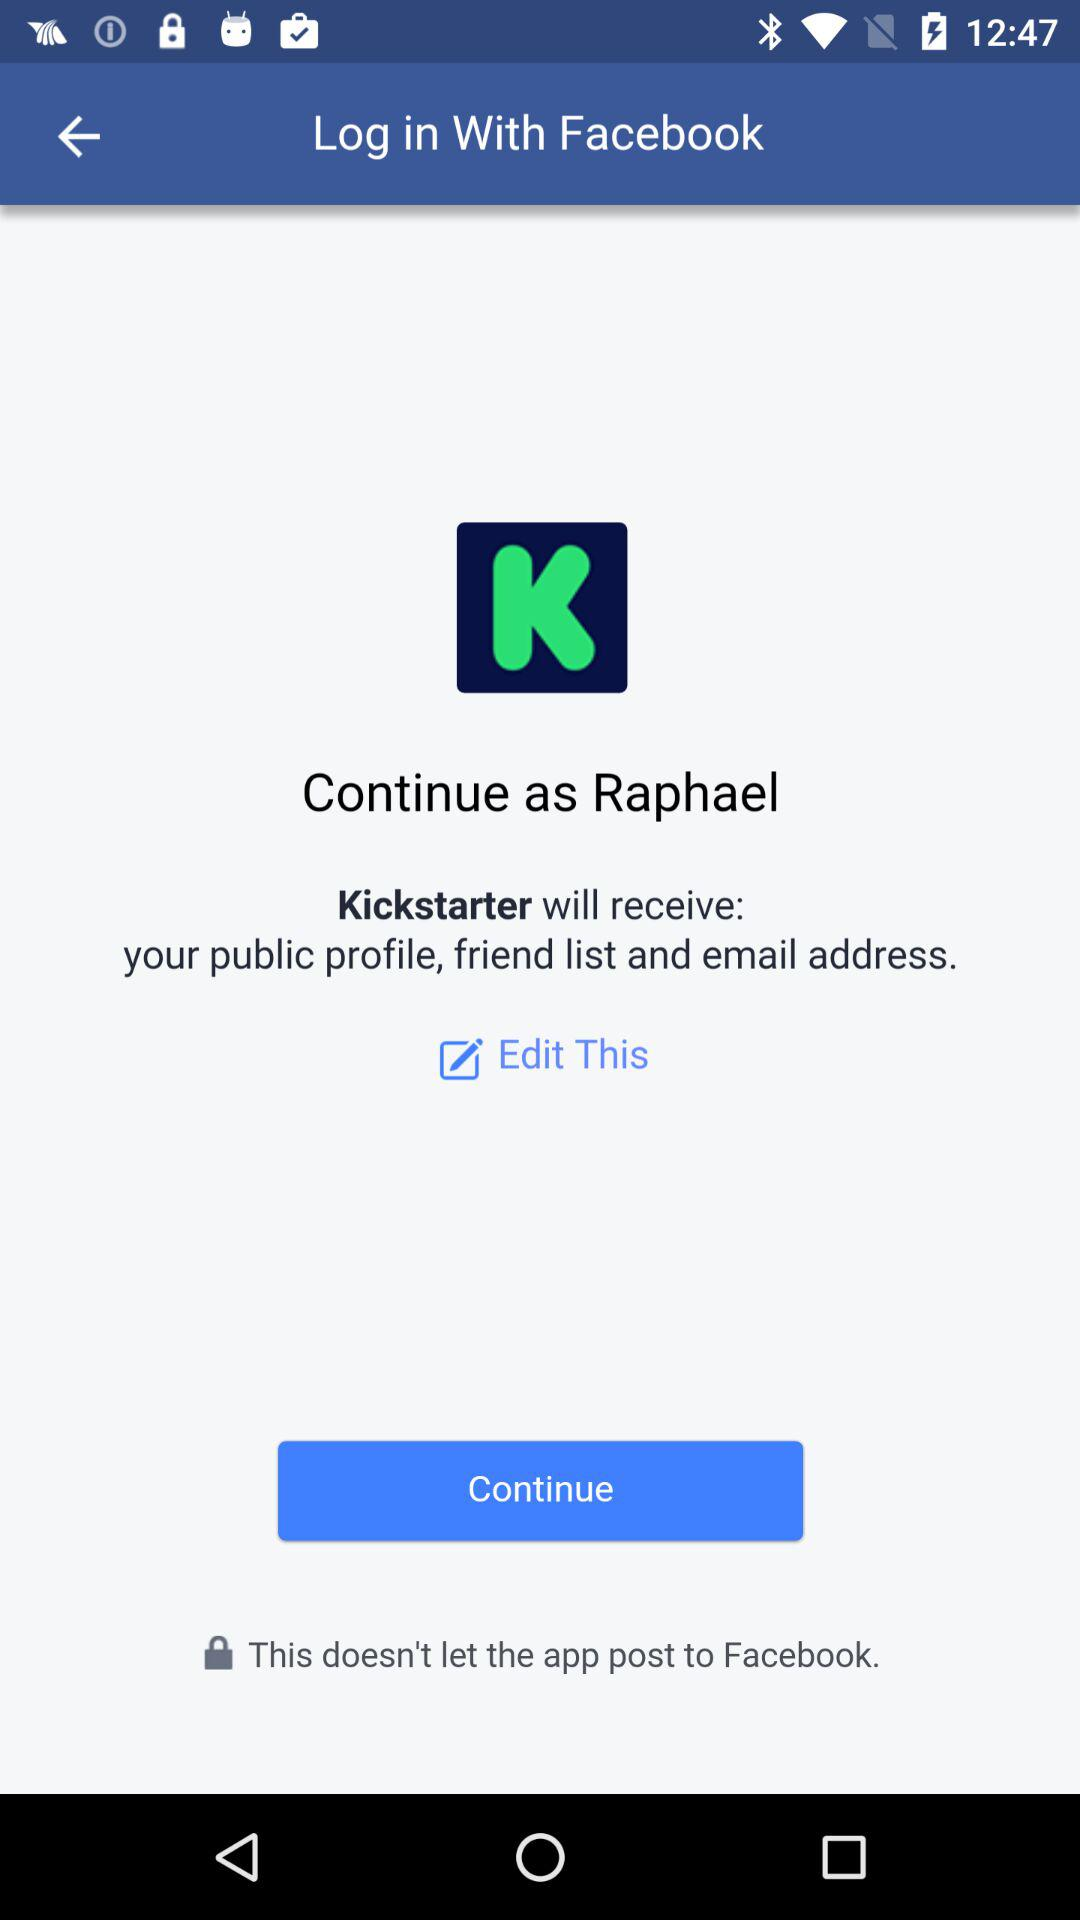What application can be used to log in? The application that can be used to log in is "Facebook". 